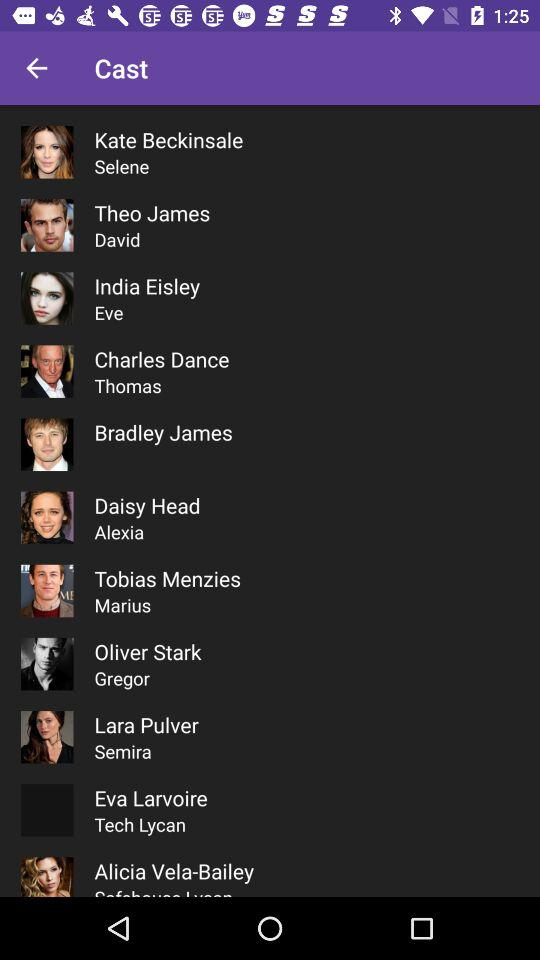Which role did Theo James play? Theo James played the role of David. 